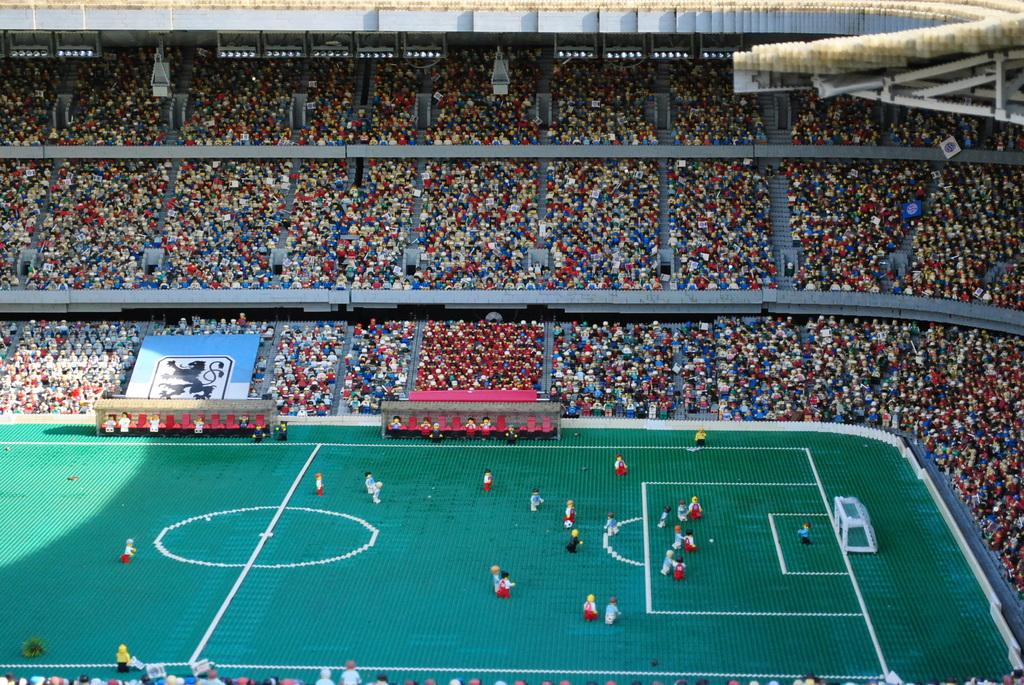What is the main subject of the image? The main subject of the image is a Lego set. What is included in the Lego set? The Lego set includes a football ground. What can be seen on the left side of the image? There is a board on the left side of the image. What type of oven is used to bake the agreement in the image? There is no oven or agreement present in the image; it features a Lego set with a football ground and a board on the left side. 